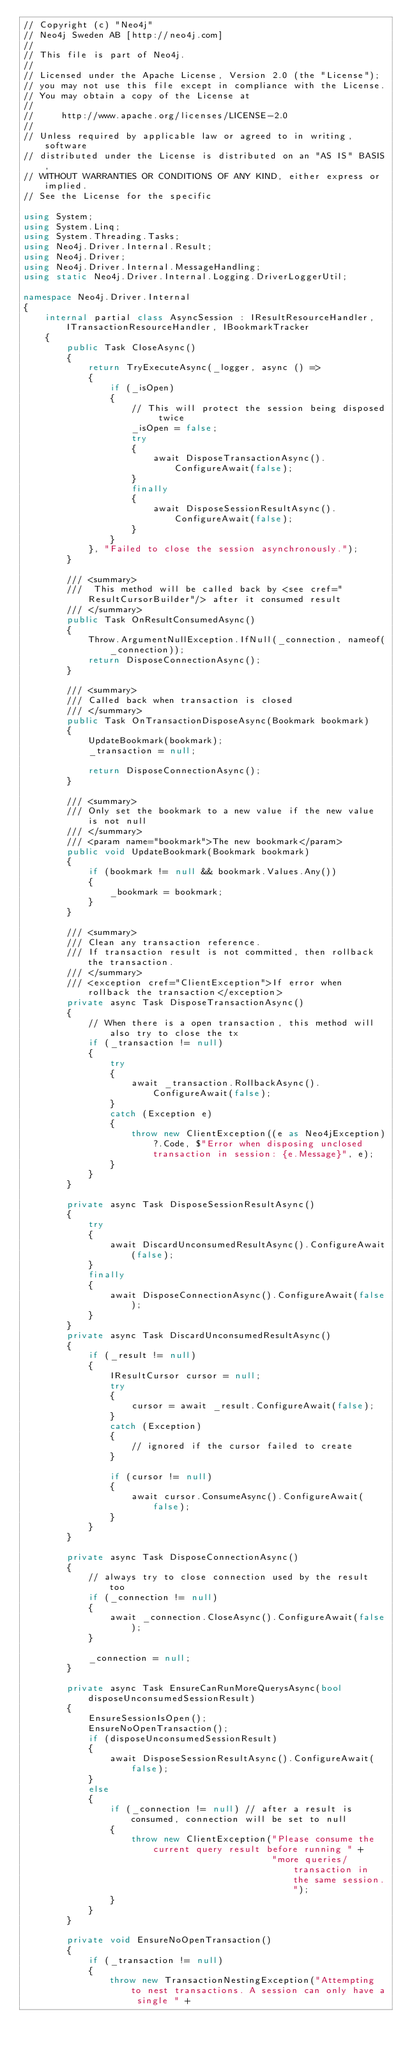Convert code to text. <code><loc_0><loc_0><loc_500><loc_500><_C#_>// Copyright (c) "Neo4j"
// Neo4j Sweden AB [http://neo4j.com]
//
// This file is part of Neo4j.
//
// Licensed under the Apache License, Version 2.0 (the "License");
// you may not use this file except in compliance with the License.
// You may obtain a copy of the License at
//
//     http://www.apache.org/licenses/LICENSE-2.0
//
// Unless required by applicable law or agreed to in writing, software
// distributed under the License is distributed on an "AS IS" BASIS,
// WITHOUT WARRANTIES OR CONDITIONS OF ANY KIND, either express or implied.
// See the License for the specific

using System;
using System.Linq;
using System.Threading.Tasks;
using Neo4j.Driver.Internal.Result;
using Neo4j.Driver;
using Neo4j.Driver.Internal.MessageHandling;
using static Neo4j.Driver.Internal.Logging.DriverLoggerUtil;

namespace Neo4j.Driver.Internal
{
    internal partial class AsyncSession : IResultResourceHandler, ITransactionResourceHandler, IBookmarkTracker
    {
        public Task CloseAsync()
        {
            return TryExecuteAsync(_logger, async () =>
            {
                if (_isOpen)
                {
                    // This will protect the session being disposed twice
                    _isOpen = false;
                    try
                    {
                        await DisposeTransactionAsync().ConfigureAwait(false);
                    }
                    finally
                    {
                        await DisposeSessionResultAsync().ConfigureAwait(false);
                    }
                }
            }, "Failed to close the session asynchronously.");
        }

        /// <summary>
        ///  This method will be called back by <see cref="ResultCursorBuilder"/> after it consumed result
        /// </summary>
        public Task OnResultConsumedAsync()
        {
            Throw.ArgumentNullException.IfNull(_connection, nameof(_connection));
            return DisposeConnectionAsync();
        }

        /// <summary>
        /// Called back when transaction is closed
        /// </summary>
        public Task OnTransactionDisposeAsync(Bookmark bookmark)
        {
            UpdateBookmark(bookmark);
            _transaction = null;

            return DisposeConnectionAsync();
        }

        /// <summary>
        /// Only set the bookmark to a new value if the new value is not null
        /// </summary>
        /// <param name="bookmark">The new bookmark</param>
        public void UpdateBookmark(Bookmark bookmark)
        {
            if (bookmark != null && bookmark.Values.Any())
            {
                _bookmark = bookmark;
            }
        }

        /// <summary>
        /// Clean any transaction reference.
        /// If transaction result is not committed, then rollback the transaction.
        /// </summary>
        /// <exception cref="ClientException">If error when rollback the transaction</exception>
        private async Task DisposeTransactionAsync()
        {
            // When there is a open transaction, this method will also try to close the tx
            if (_transaction != null)
            {	
				try
                {
                    await _transaction.RollbackAsync().ConfigureAwait(false);
                }
				catch (Exception e)
                {	
					throw new ClientException((e as Neo4jException)?.Code, $"Error when disposing unclosed transaction in session: {e.Message}", e);
				}
            }
        }

        private async Task DisposeSessionResultAsync()
        {
            try
            {
                await DiscardUnconsumedResultAsync().ConfigureAwait(false);
            }
            finally
            {
                await DisposeConnectionAsync().ConfigureAwait(false);
            }
        }
        private async Task DiscardUnconsumedResultAsync()
        {
            if (_result != null)
            {
                IResultCursor cursor = null;
                try
                {
                    cursor = await _result.ConfigureAwait(false);
                }
                catch (Exception)
                {
                    // ignored if the cursor failed to create
                }

                if (cursor != null)
                {
                    await cursor.ConsumeAsync().ConfigureAwait(false);
                }
            }
        }

        private async Task DisposeConnectionAsync()
        {
            // always try to close connection used by the result too
            if (_connection != null)
            {
                await _connection.CloseAsync().ConfigureAwait(false);
            }

            _connection = null;
        }

        private async Task EnsureCanRunMoreQuerysAsync(bool disposeUnconsumedSessionResult)
        {
            EnsureSessionIsOpen();
            EnsureNoOpenTransaction();
            if (disposeUnconsumedSessionResult)
            {
                await DisposeSessionResultAsync().ConfigureAwait(false);
            }
            else
            {
                if (_connection != null) // after a result is consumed, connection will be set to null
                {
                    throw new ClientException("Please consume the current query result before running " +
                                              "more queries/transaction in the same session.");
                }
            }
        }

        private void EnsureNoOpenTransaction()
        {
            if (_transaction != null)
            {
				throw new TransactionNestingException("Attempting to nest transactions. A session can only have a single " +</code> 